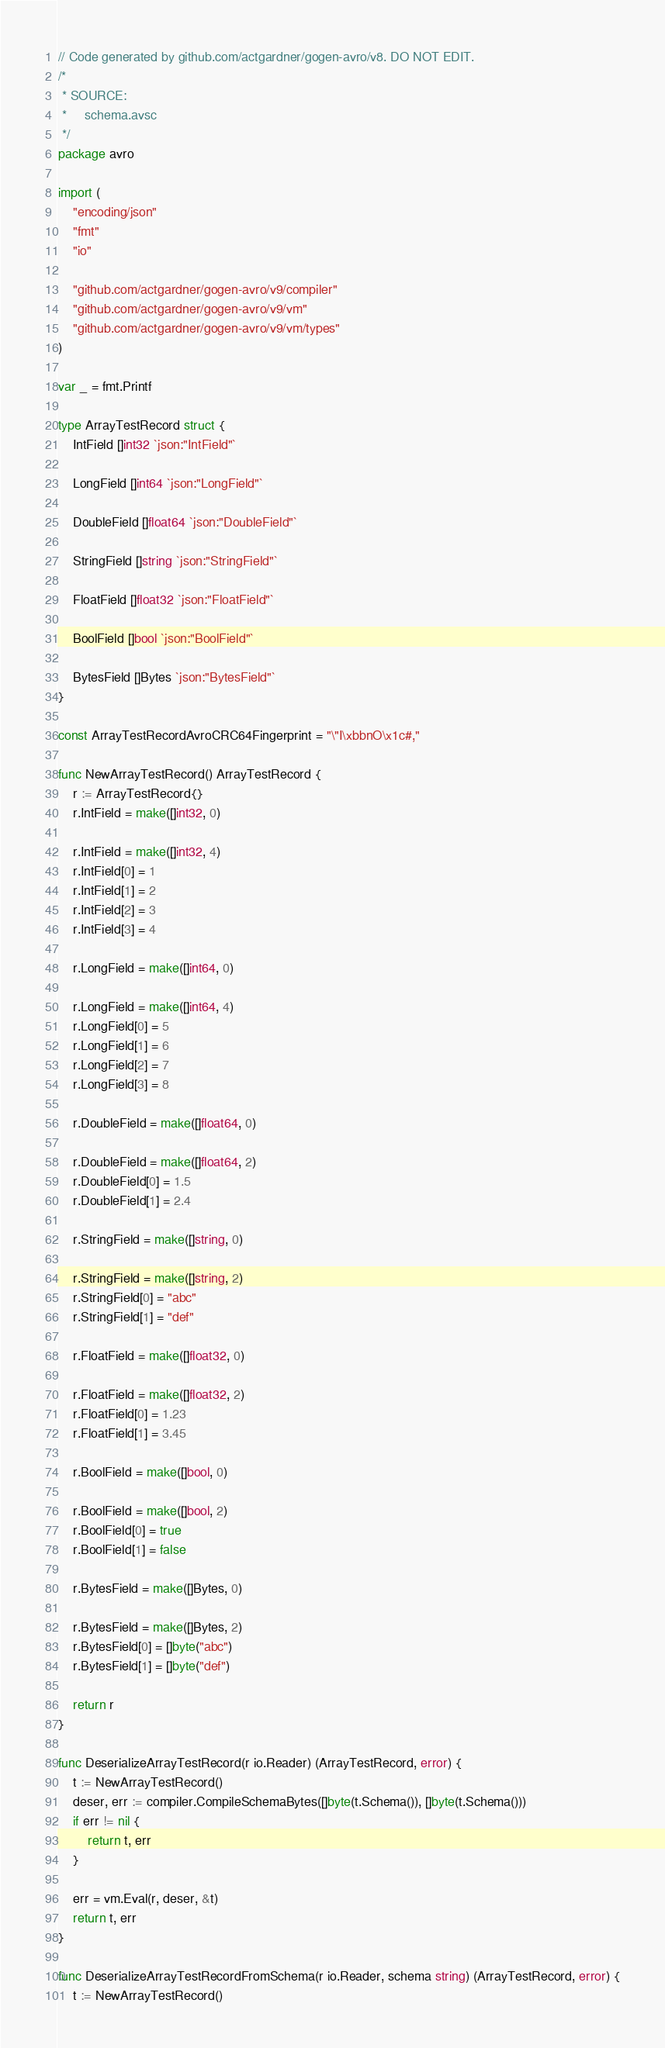Convert code to text. <code><loc_0><loc_0><loc_500><loc_500><_Go_>// Code generated by github.com/actgardner/gogen-avro/v8. DO NOT EDIT.
/*
 * SOURCE:
 *     schema.avsc
 */
package avro

import (
	"encoding/json"
	"fmt"
	"io"

	"github.com/actgardner/gogen-avro/v9/compiler"
	"github.com/actgardner/gogen-avro/v9/vm"
	"github.com/actgardner/gogen-avro/v9/vm/types"
)

var _ = fmt.Printf

type ArrayTestRecord struct {
	IntField []int32 `json:"IntField"`

	LongField []int64 `json:"LongField"`

	DoubleField []float64 `json:"DoubleField"`

	StringField []string `json:"StringField"`

	FloatField []float32 `json:"FloatField"`

	BoolField []bool `json:"BoolField"`

	BytesField []Bytes `json:"BytesField"`
}

const ArrayTestRecordAvroCRC64Fingerprint = "\"I\xbbnO\x1c#,"

func NewArrayTestRecord() ArrayTestRecord {
	r := ArrayTestRecord{}
	r.IntField = make([]int32, 0)

	r.IntField = make([]int32, 4)
	r.IntField[0] = 1
	r.IntField[1] = 2
	r.IntField[2] = 3
	r.IntField[3] = 4

	r.LongField = make([]int64, 0)

	r.LongField = make([]int64, 4)
	r.LongField[0] = 5
	r.LongField[1] = 6
	r.LongField[2] = 7
	r.LongField[3] = 8

	r.DoubleField = make([]float64, 0)

	r.DoubleField = make([]float64, 2)
	r.DoubleField[0] = 1.5
	r.DoubleField[1] = 2.4

	r.StringField = make([]string, 0)

	r.StringField = make([]string, 2)
	r.StringField[0] = "abc"
	r.StringField[1] = "def"

	r.FloatField = make([]float32, 0)

	r.FloatField = make([]float32, 2)
	r.FloatField[0] = 1.23
	r.FloatField[1] = 3.45

	r.BoolField = make([]bool, 0)

	r.BoolField = make([]bool, 2)
	r.BoolField[0] = true
	r.BoolField[1] = false

	r.BytesField = make([]Bytes, 0)

	r.BytesField = make([]Bytes, 2)
	r.BytesField[0] = []byte("abc")
	r.BytesField[1] = []byte("def")

	return r
}

func DeserializeArrayTestRecord(r io.Reader) (ArrayTestRecord, error) {
	t := NewArrayTestRecord()
	deser, err := compiler.CompileSchemaBytes([]byte(t.Schema()), []byte(t.Schema()))
	if err != nil {
		return t, err
	}

	err = vm.Eval(r, deser, &t)
	return t, err
}

func DeserializeArrayTestRecordFromSchema(r io.Reader, schema string) (ArrayTestRecord, error) {
	t := NewArrayTestRecord()
</code> 